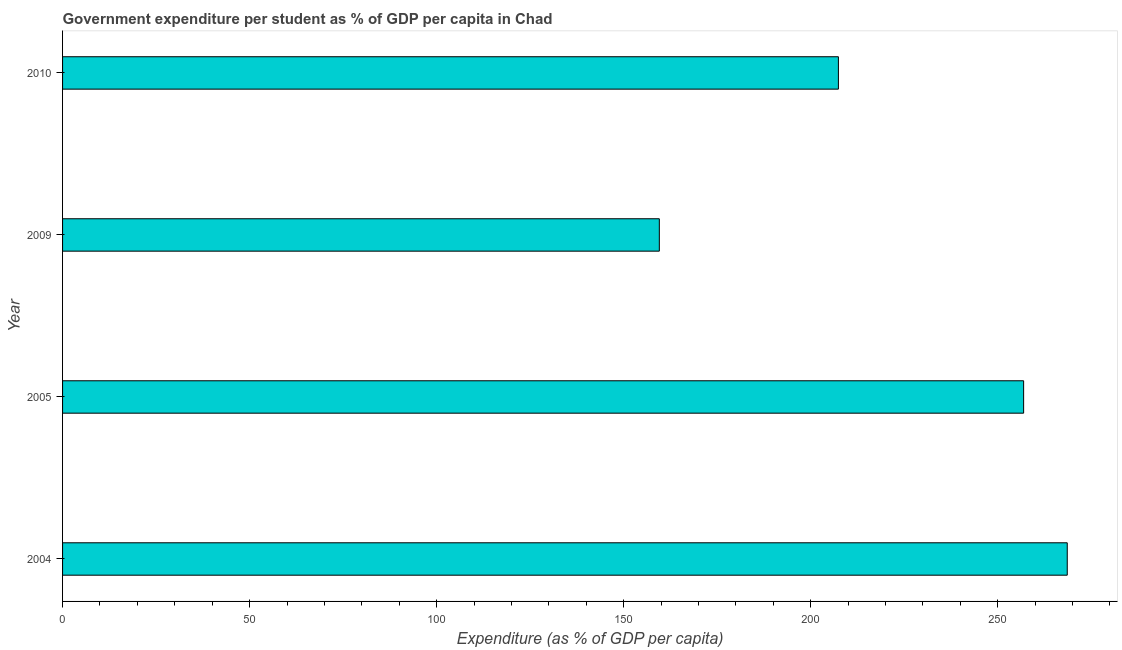Does the graph contain grids?
Offer a terse response. No. What is the title of the graph?
Ensure brevity in your answer.  Government expenditure per student as % of GDP per capita in Chad. What is the label or title of the X-axis?
Provide a succinct answer. Expenditure (as % of GDP per capita). What is the government expenditure per student in 2004?
Your answer should be compact. 268.59. Across all years, what is the maximum government expenditure per student?
Ensure brevity in your answer.  268.59. Across all years, what is the minimum government expenditure per student?
Give a very brief answer. 159.53. In which year was the government expenditure per student maximum?
Offer a terse response. 2004. In which year was the government expenditure per student minimum?
Ensure brevity in your answer.  2009. What is the sum of the government expenditure per student?
Provide a short and direct response. 892.45. What is the difference between the government expenditure per student in 2004 and 2009?
Ensure brevity in your answer.  109.06. What is the average government expenditure per student per year?
Make the answer very short. 223.11. What is the median government expenditure per student?
Give a very brief answer. 232.17. In how many years, is the government expenditure per student greater than 80 %?
Provide a short and direct response. 4. Do a majority of the years between 2004 and 2005 (inclusive) have government expenditure per student greater than 160 %?
Your response must be concise. Yes. What is the ratio of the government expenditure per student in 2004 to that in 2010?
Offer a very short reply. 1.29. What is the difference between the highest and the second highest government expenditure per student?
Keep it short and to the point. 11.66. What is the difference between the highest and the lowest government expenditure per student?
Your response must be concise. 109.05. How many bars are there?
Provide a short and direct response. 4. Are all the bars in the graph horizontal?
Give a very brief answer. Yes. How many years are there in the graph?
Your response must be concise. 4. What is the difference between two consecutive major ticks on the X-axis?
Your answer should be very brief. 50. What is the Expenditure (as % of GDP per capita) in 2004?
Keep it short and to the point. 268.59. What is the Expenditure (as % of GDP per capita) in 2005?
Your answer should be very brief. 256.93. What is the Expenditure (as % of GDP per capita) in 2009?
Your response must be concise. 159.53. What is the Expenditure (as % of GDP per capita) in 2010?
Keep it short and to the point. 207.41. What is the difference between the Expenditure (as % of GDP per capita) in 2004 and 2005?
Provide a succinct answer. 11.66. What is the difference between the Expenditure (as % of GDP per capita) in 2004 and 2009?
Provide a succinct answer. 109.05. What is the difference between the Expenditure (as % of GDP per capita) in 2004 and 2010?
Your answer should be very brief. 61.18. What is the difference between the Expenditure (as % of GDP per capita) in 2005 and 2009?
Keep it short and to the point. 97.39. What is the difference between the Expenditure (as % of GDP per capita) in 2005 and 2010?
Give a very brief answer. 49.52. What is the difference between the Expenditure (as % of GDP per capita) in 2009 and 2010?
Make the answer very short. -47.87. What is the ratio of the Expenditure (as % of GDP per capita) in 2004 to that in 2005?
Offer a very short reply. 1.04. What is the ratio of the Expenditure (as % of GDP per capita) in 2004 to that in 2009?
Keep it short and to the point. 1.68. What is the ratio of the Expenditure (as % of GDP per capita) in 2004 to that in 2010?
Make the answer very short. 1.29. What is the ratio of the Expenditure (as % of GDP per capita) in 2005 to that in 2009?
Provide a short and direct response. 1.61. What is the ratio of the Expenditure (as % of GDP per capita) in 2005 to that in 2010?
Provide a succinct answer. 1.24. What is the ratio of the Expenditure (as % of GDP per capita) in 2009 to that in 2010?
Offer a very short reply. 0.77. 